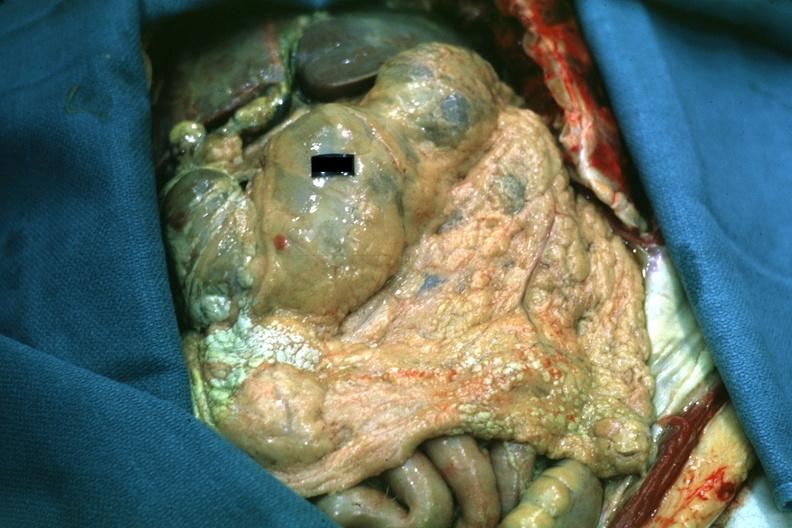s all the fat necrosis not clear?
Answer the question using a single word or phrase. Yes 